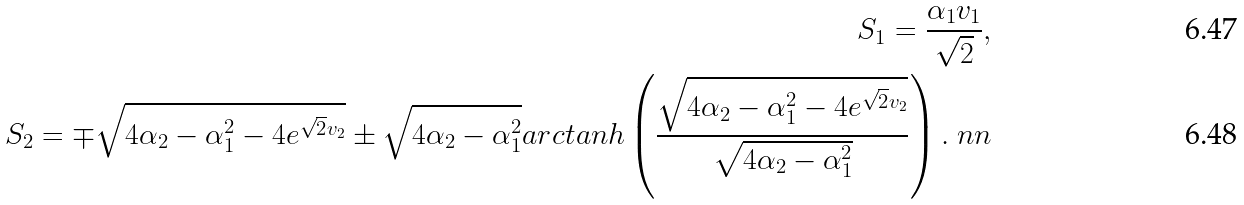<formula> <loc_0><loc_0><loc_500><loc_500>S _ { 1 } = \frac { \alpha _ { 1 } v _ { 1 } } { \sqrt { 2 } } , \\ S _ { 2 } = \mp \sqrt { 4 \alpha _ { 2 } - \alpha _ { 1 } ^ { 2 } - 4 e ^ { \sqrt { 2 } v _ { 2 } } } \pm \sqrt { 4 \alpha _ { 2 } - \alpha _ { 1 } ^ { 2 } } a r c t a n h \left ( \frac { \sqrt { 4 \alpha _ { 2 } - \alpha _ { 1 } ^ { 2 } - 4 e ^ { \sqrt { 2 } v _ { 2 } } } } { \sqrt { 4 \alpha _ { 2 } - \alpha _ { 1 } ^ { 2 } } } \right ) . \ n n</formula> 